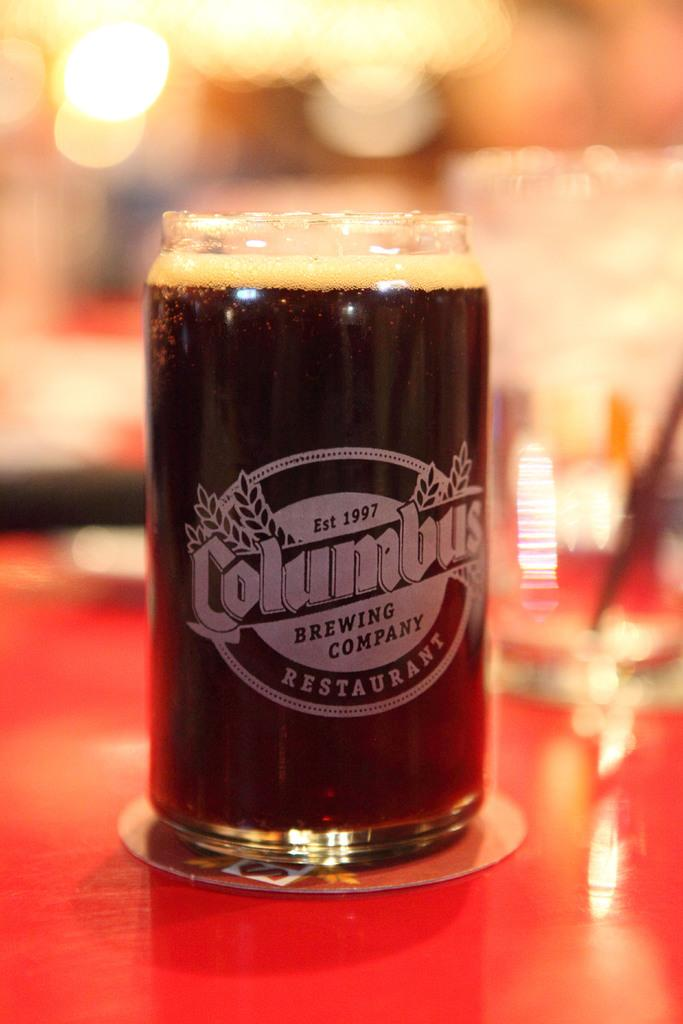<image>
Summarize the visual content of the image. A glass of beer fizzes in a glass labeled  Columbus Brewing Company 